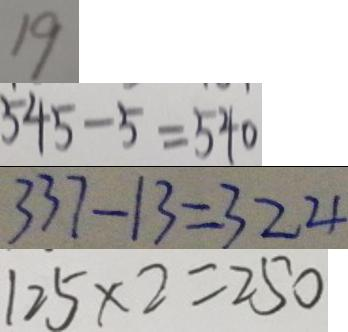<formula> <loc_0><loc_0><loc_500><loc_500>1 9 
 5 4 5 - 5 = 5 4 0 
 3 3 7 - 1 3 = 3 2 4 
 1 2 5 \times 2 = 2 5 0</formula> 